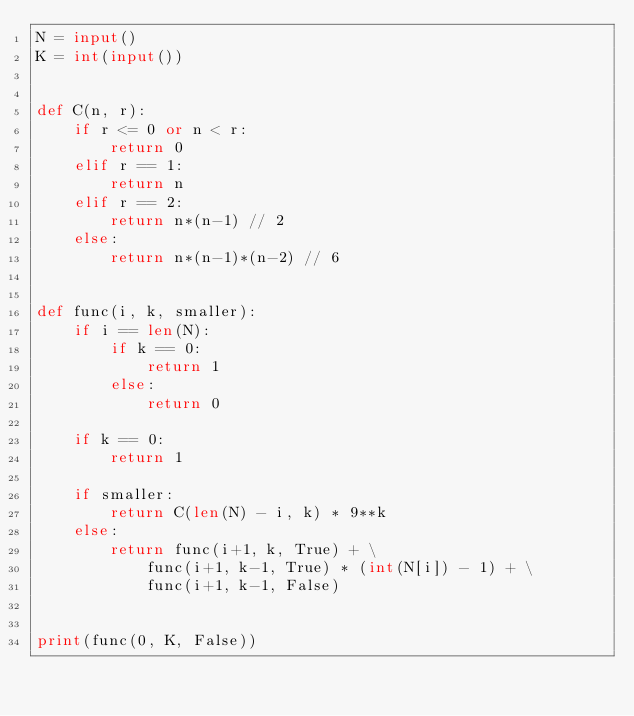Convert code to text. <code><loc_0><loc_0><loc_500><loc_500><_Python_>N = input()
K = int(input())


def C(n, r):
    if r <= 0 or n < r:
        return 0
    elif r == 1:
        return n
    elif r == 2:
        return n*(n-1) // 2
    else:
        return n*(n-1)*(n-2) // 6


def func(i, k, smaller):
    if i == len(N):
        if k == 0:
            return 1
        else:
            return 0

    if k == 0:
        return 1

    if smaller:
        return C(len(N) - i, k) * 9**k
    else:
        return func(i+1, k, True) + \
            func(i+1, k-1, True) * (int(N[i]) - 1) + \
            func(i+1, k-1, False)


print(func(0, K, False))
</code> 